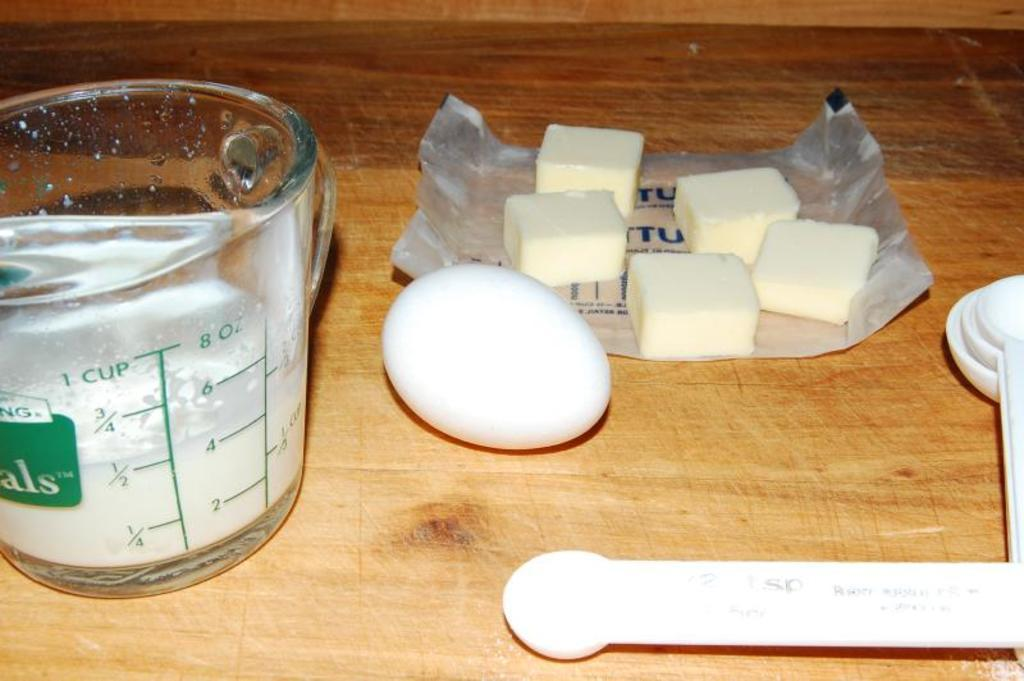<image>
Provide a brief description of the given image. a measuring cup, egg and spoon and butter on the counter 